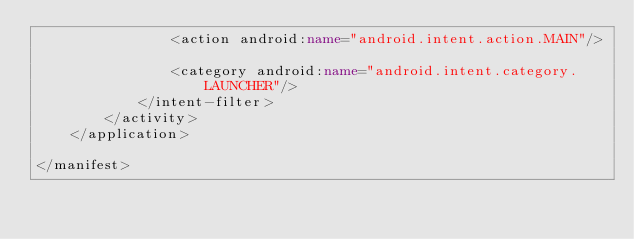Convert code to text. <code><loc_0><loc_0><loc_500><loc_500><_XML_>                <action android:name="android.intent.action.MAIN"/>

                <category android:name="android.intent.category.LAUNCHER"/>
            </intent-filter>
        </activity>
    </application>

</manifest></code> 